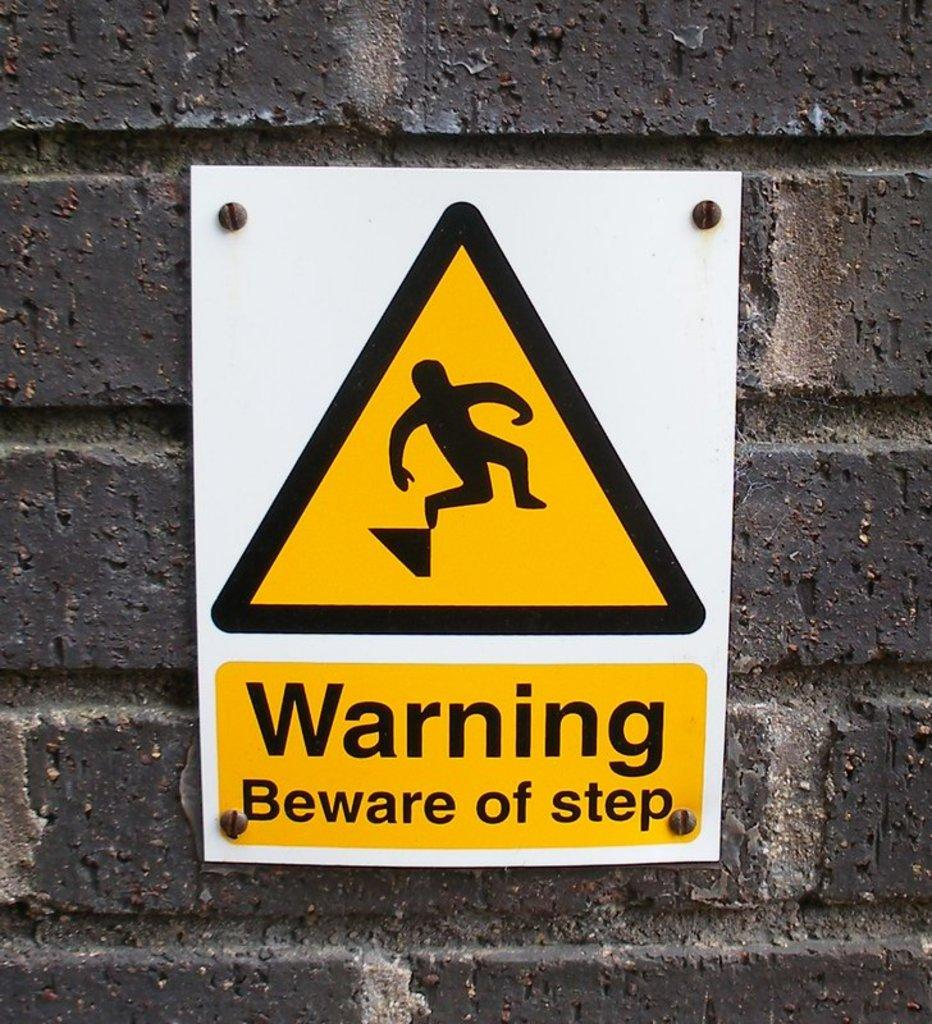<image>
Give a short and clear explanation of the subsequent image. a warning sign with a black figure on it 